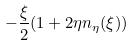Convert formula to latex. <formula><loc_0><loc_0><loc_500><loc_500>- \frac { \xi } { 2 } ( 1 + 2 \eta n _ { \eta } ( \xi ) )</formula> 